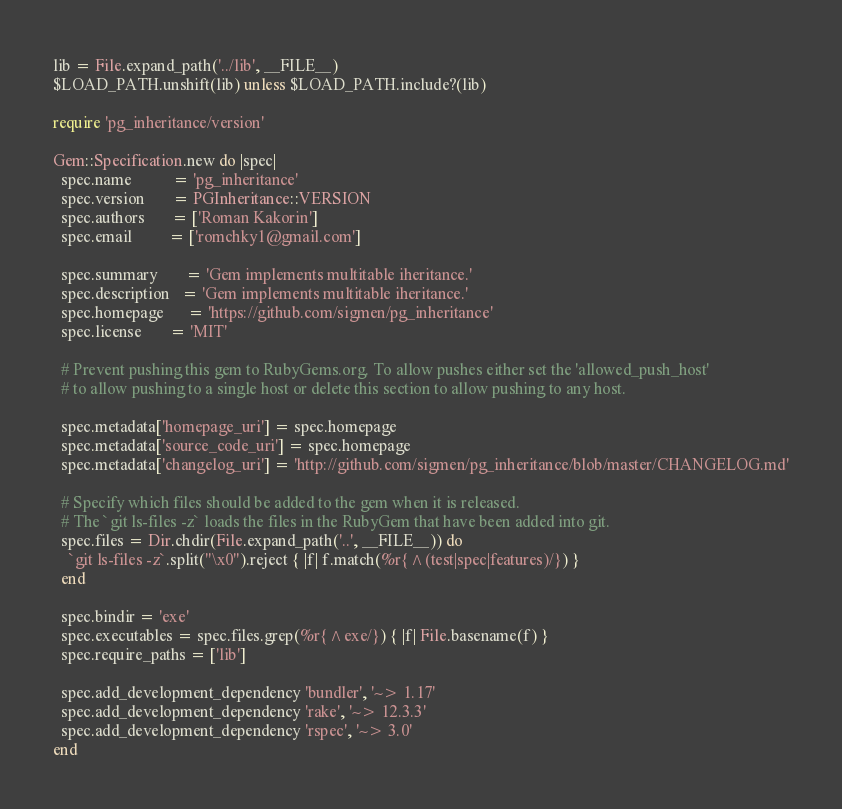Convert code to text. <code><loc_0><loc_0><loc_500><loc_500><_Ruby_>lib = File.expand_path('../lib', __FILE__)
$LOAD_PATH.unshift(lib) unless $LOAD_PATH.include?(lib)

require 'pg_inheritance/version'

Gem::Specification.new do |spec|
  spec.name          = 'pg_inheritance'
  spec.version       = PGInheritance::VERSION
  spec.authors       = ['Roman Kakorin']
  spec.email         = ['romchky1@gmail.com']

  spec.summary       = 'Gem implements multitable iheritance.'
  spec.description   = 'Gem implements multitable iheritance.'
  spec.homepage      = 'https://github.com/sigmen/pg_inheritance'
  spec.license       = 'MIT'

  # Prevent pushing this gem to RubyGems.org. To allow pushes either set the 'allowed_push_host'
  # to allow pushing to a single host or delete this section to allow pushing to any host.

  spec.metadata['homepage_uri'] = spec.homepage
  spec.metadata['source_code_uri'] = spec.homepage
  spec.metadata['changelog_uri'] = 'http://github.com/sigmen/pg_inheritance/blob/master/CHANGELOG.md'

  # Specify which files should be added to the gem when it is released.
  # The `git ls-files -z` loads the files in the RubyGem that have been added into git.
  spec.files = Dir.chdir(File.expand_path('..', __FILE__)) do
    `git ls-files -z`.split("\x0").reject { |f| f.match(%r{^(test|spec|features)/}) }
  end

  spec.bindir = 'exe'
  spec.executables = spec.files.grep(%r{^exe/}) { |f| File.basename(f) }
  spec.require_paths = ['lib']

  spec.add_development_dependency 'bundler', '~> 1.17'
  spec.add_development_dependency 'rake', '~> 12.3.3'
  spec.add_development_dependency 'rspec', '~> 3.0'
end
</code> 